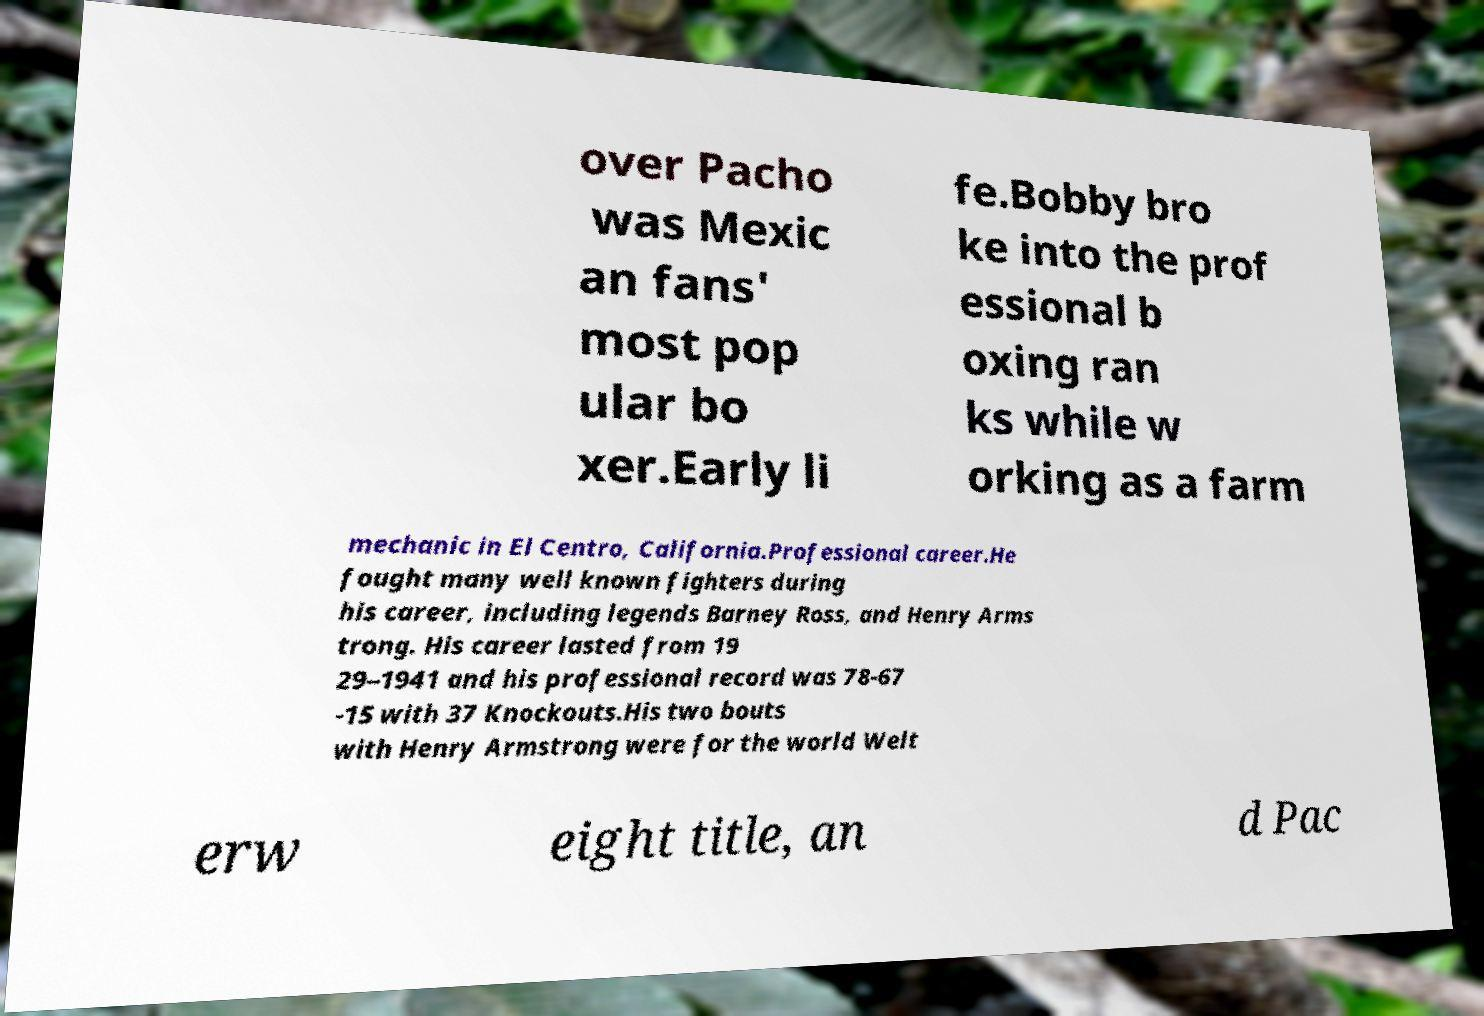Please identify and transcribe the text found in this image. over Pacho was Mexic an fans' most pop ular bo xer.Early li fe.Bobby bro ke into the prof essional b oxing ran ks while w orking as a farm mechanic in El Centro, California.Professional career.He fought many well known fighters during his career, including legends Barney Ross, and Henry Arms trong. His career lasted from 19 29–1941 and his professional record was 78-67 -15 with 37 Knockouts.His two bouts with Henry Armstrong were for the world Welt erw eight title, an d Pac 